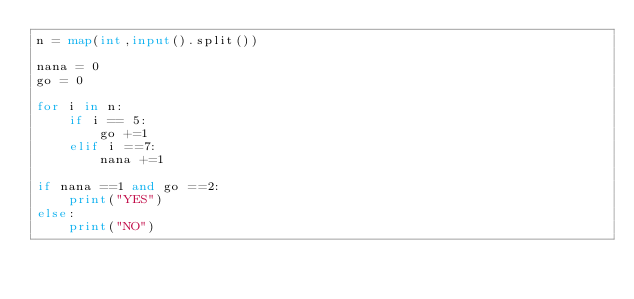Convert code to text. <code><loc_0><loc_0><loc_500><loc_500><_Python_>n = map(int,input().split())

nana = 0
go = 0

for i in n:
    if i == 5:
        go +=1
    elif i ==7:
        nana +=1

if nana ==1 and go ==2:
    print("YES")
else:
    print("NO")</code> 